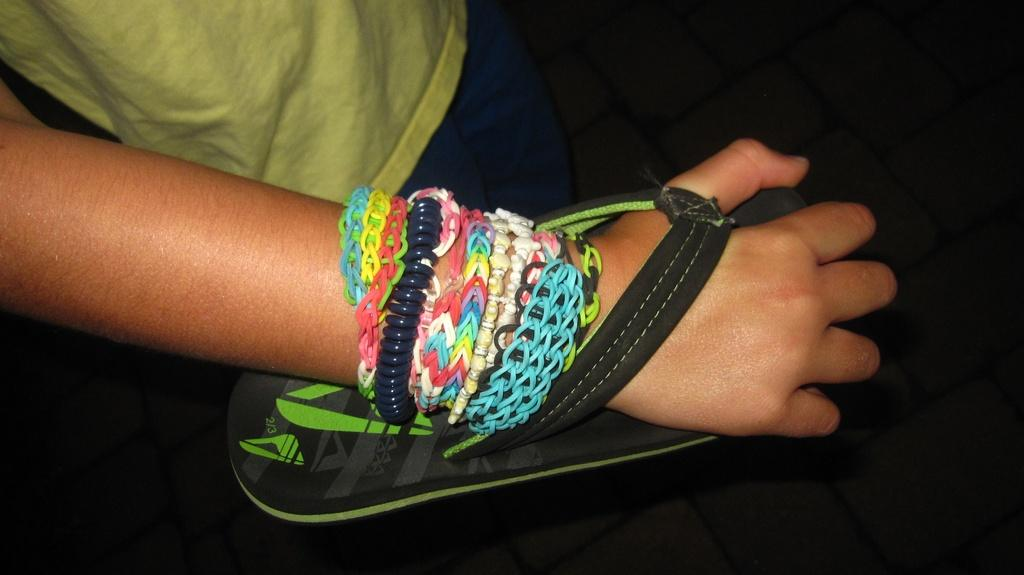What part of the person's body is visible in the image? There is a person's hand in the image. What is on the person's hand? There are bands on the person's hand. What type of footwear is present in the image? There is a slipper in the image. What type of wool is being spun in the image? There is no wool or spinning activity present in the image. Is the person in the image reading a fiction book? There is no person reading a book in the image, so it cannot be determined if they are reading fiction or not. 